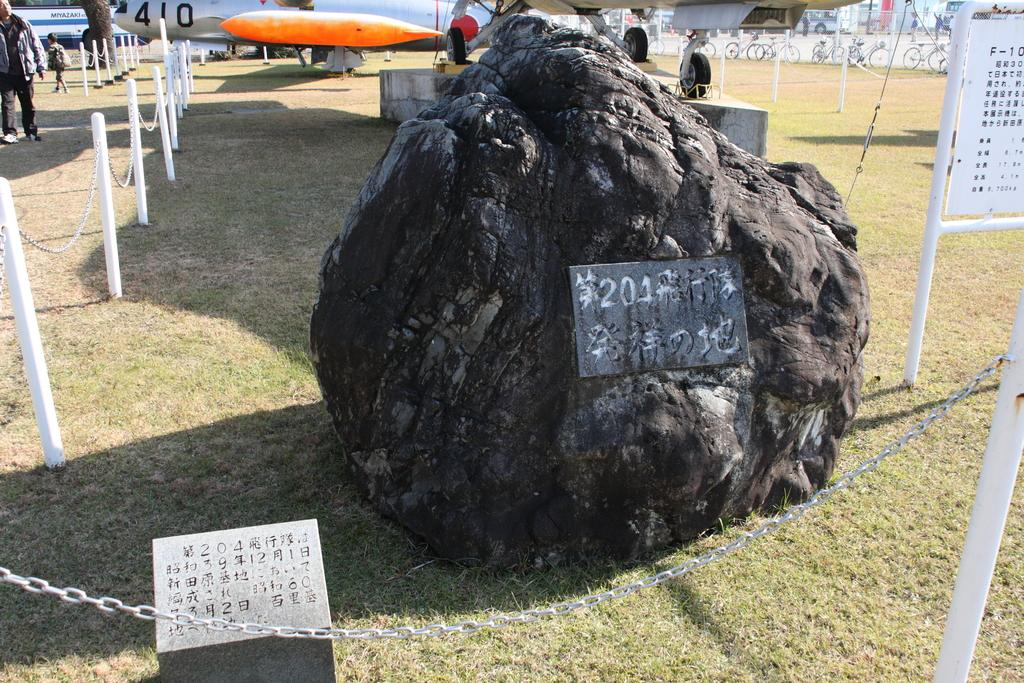What is the main subject in the center of the image? There is a rock in the center of the image. What can be seen on the right side of the image? There is a board on the right side of the image. What is located at the bottom of the image? There is a fence at the bottom of the image. What is visible in the background of the image? There are people, aeroplanes, and bicycles visible in the background of the image. What type of beam is being used by the people in the image? There is no beam visible or mentioned in the image; it features a rock, a board, a fence, and background elements such as people, aeroplanes, and bicycles. Why are the people in the image crying? There is no indication in the image that the people are crying; they are simply visible in the background. 